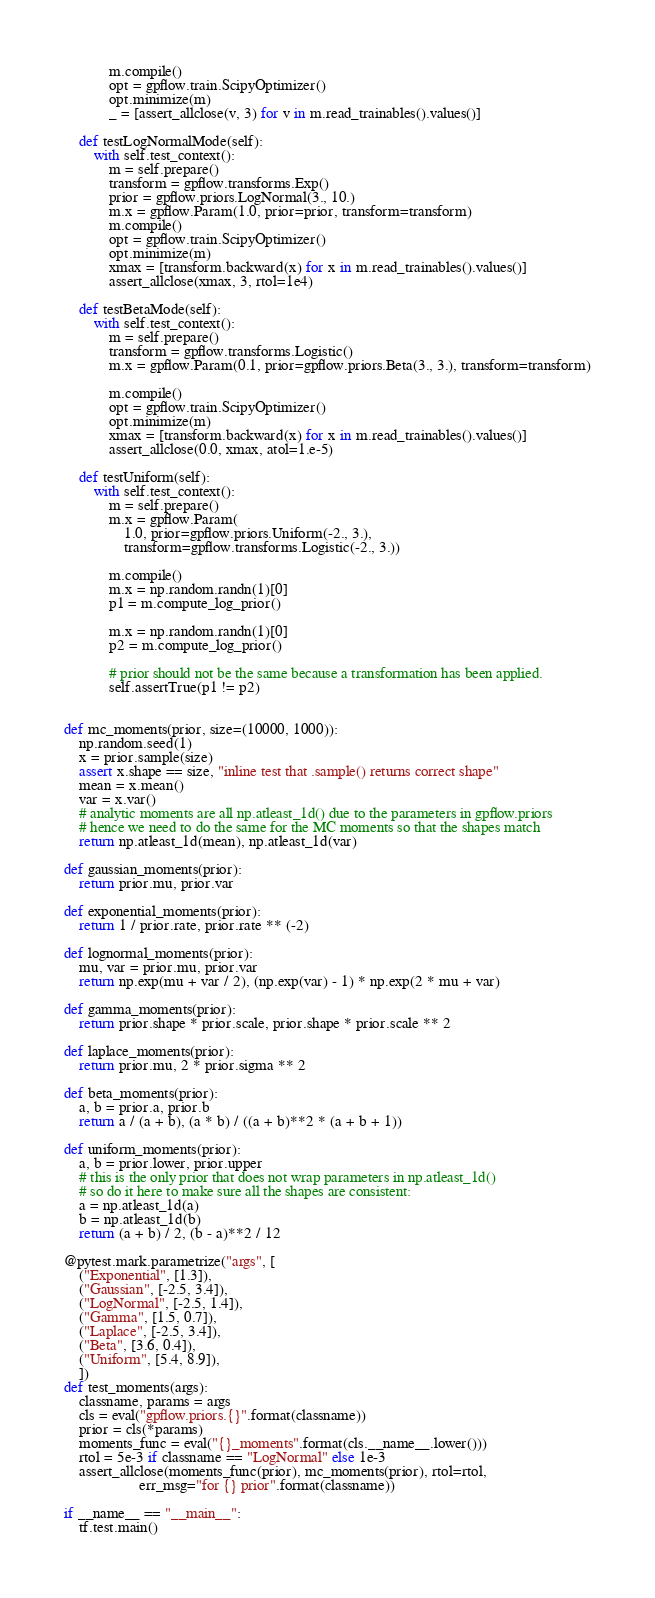Convert code to text. <code><loc_0><loc_0><loc_500><loc_500><_Python_>            m.compile()
            opt = gpflow.train.ScipyOptimizer()
            opt.minimize(m)
            _ = [assert_allclose(v, 3) for v in m.read_trainables().values()]

    def testLogNormalMode(self):
        with self.test_context():
            m = self.prepare()
            transform = gpflow.transforms.Exp()
            prior = gpflow.priors.LogNormal(3., 10.)
            m.x = gpflow.Param(1.0, prior=prior, transform=transform)
            m.compile()
            opt = gpflow.train.ScipyOptimizer()
            opt.minimize(m)
            xmax = [transform.backward(x) for x in m.read_trainables().values()]
            assert_allclose(xmax, 3, rtol=1e4)

    def testBetaMode(self):
        with self.test_context():
            m = self.prepare()
            transform = gpflow.transforms.Logistic()
            m.x = gpflow.Param(0.1, prior=gpflow.priors.Beta(3., 3.), transform=transform)

            m.compile()
            opt = gpflow.train.ScipyOptimizer()
            opt.minimize(m)
            xmax = [transform.backward(x) for x in m.read_trainables().values()]
            assert_allclose(0.0, xmax, atol=1.e-5)

    def testUniform(self):
        with self.test_context():
            m = self.prepare()
            m.x = gpflow.Param(
                1.0, prior=gpflow.priors.Uniform(-2., 3.),
                transform=gpflow.transforms.Logistic(-2., 3.))

            m.compile()
            m.x = np.random.randn(1)[0]
            p1 = m.compute_log_prior()

            m.x = np.random.randn(1)[0]
            p2 = m.compute_log_prior()

            # prior should not be the same because a transformation has been applied.
            self.assertTrue(p1 != p2)


def mc_moments(prior, size=(10000, 1000)):
    np.random.seed(1)
    x = prior.sample(size)
    assert x.shape == size, "inline test that .sample() returns correct shape"
    mean = x.mean()
    var = x.var()
    # analytic moments are all np.atleast_1d() due to the parameters in gpflow.priors
    # hence we need to do the same for the MC moments so that the shapes match
    return np.atleast_1d(mean), np.atleast_1d(var)

def gaussian_moments(prior):
    return prior.mu, prior.var

def exponential_moments(prior):
    return 1 / prior.rate, prior.rate ** (-2)

def lognormal_moments(prior):
    mu, var = prior.mu, prior.var
    return np.exp(mu + var / 2), (np.exp(var) - 1) * np.exp(2 * mu + var)

def gamma_moments(prior):
    return prior.shape * prior.scale, prior.shape * prior.scale ** 2

def laplace_moments(prior):
    return prior.mu, 2 * prior.sigma ** 2

def beta_moments(prior):
    a, b = prior.a, prior.b
    return a / (a + b), (a * b) / ((a + b)**2 * (a + b + 1))

def uniform_moments(prior):
    a, b = prior.lower, prior.upper
    # this is the only prior that does not wrap parameters in np.atleast_1d()
    # so do it here to make sure all the shapes are consistent:
    a = np.atleast_1d(a)
    b = np.atleast_1d(b)
    return (a + b) / 2, (b - a)**2 / 12

@pytest.mark.parametrize("args", [
    ("Exponential", [1.3]),
    ("Gaussian", [-2.5, 3.4]),
    ("LogNormal", [-2.5, 1.4]),
    ("Gamma", [1.5, 0.7]),
    ("Laplace", [-2.5, 3.4]),
    ("Beta", [3.6, 0.4]),
    ("Uniform", [5.4, 8.9]),
    ])
def test_moments(args):
    classname, params = args
    cls = eval("gpflow.priors.{}".format(classname))
    prior = cls(*params)
    moments_func = eval("{}_moments".format(cls.__name__.lower()))
    rtol = 5e-3 if classname == "LogNormal" else 1e-3
    assert_allclose(moments_func(prior), mc_moments(prior), rtol=rtol,
                    err_msg="for {} prior".format(classname))

if __name__ == "__main__":
    tf.test.main()
</code> 